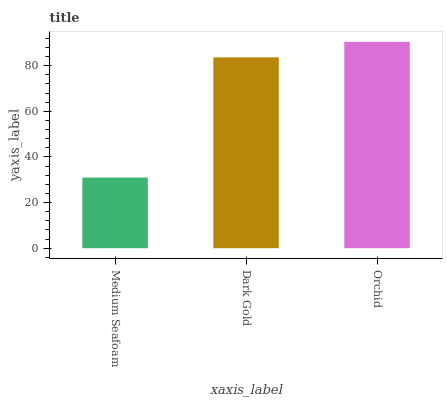Is Medium Seafoam the minimum?
Answer yes or no. Yes. Is Orchid the maximum?
Answer yes or no. Yes. Is Dark Gold the minimum?
Answer yes or no. No. Is Dark Gold the maximum?
Answer yes or no. No. Is Dark Gold greater than Medium Seafoam?
Answer yes or no. Yes. Is Medium Seafoam less than Dark Gold?
Answer yes or no. Yes. Is Medium Seafoam greater than Dark Gold?
Answer yes or no. No. Is Dark Gold less than Medium Seafoam?
Answer yes or no. No. Is Dark Gold the high median?
Answer yes or no. Yes. Is Dark Gold the low median?
Answer yes or no. Yes. Is Orchid the high median?
Answer yes or no. No. Is Orchid the low median?
Answer yes or no. No. 